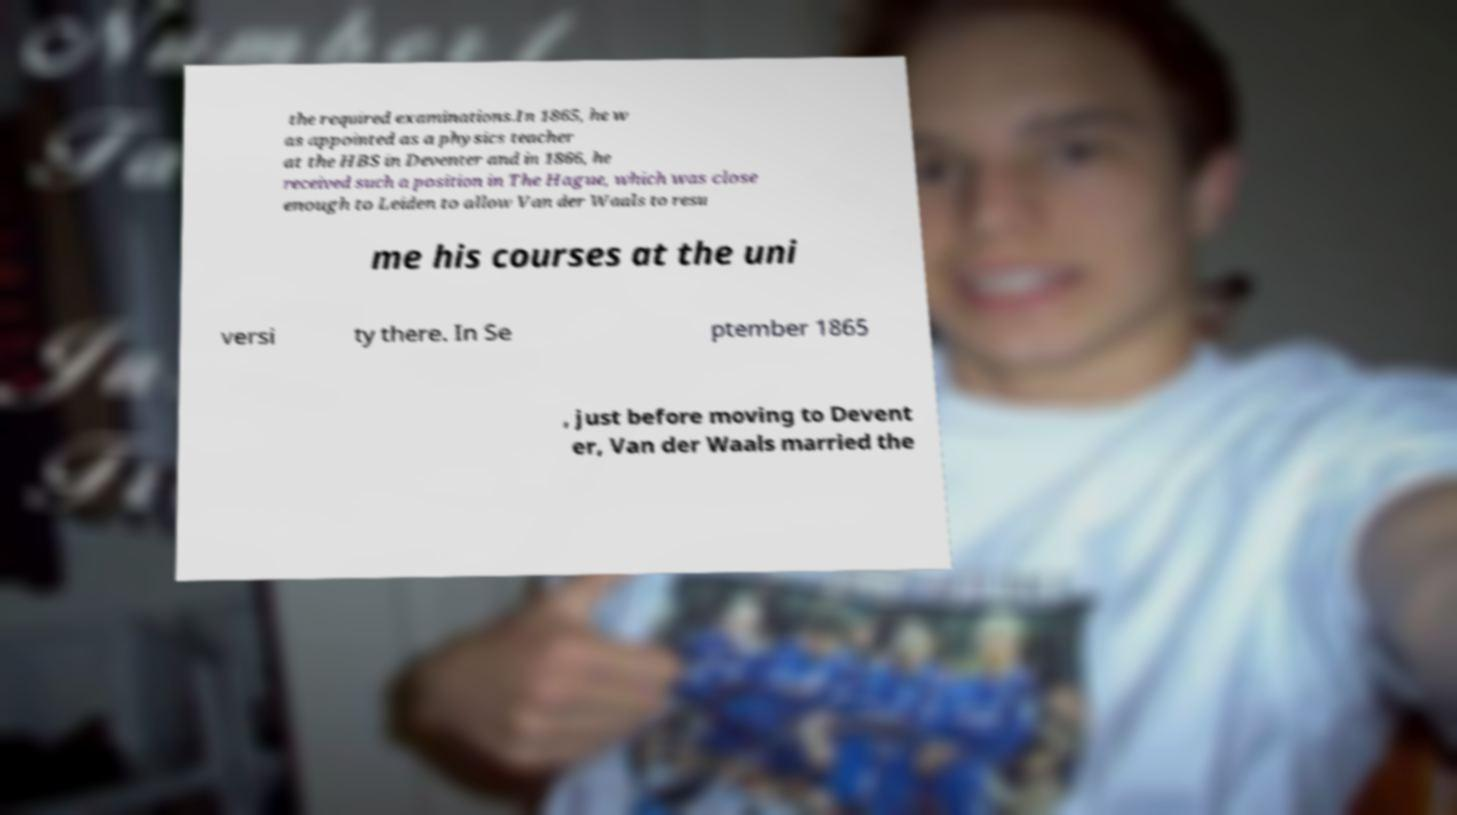What messages or text are displayed in this image? I need them in a readable, typed format. the required examinations.In 1865, he w as appointed as a physics teacher at the HBS in Deventer and in 1866, he received such a position in The Hague, which was close enough to Leiden to allow Van der Waals to resu me his courses at the uni versi ty there. In Se ptember 1865 , just before moving to Devent er, Van der Waals married the 